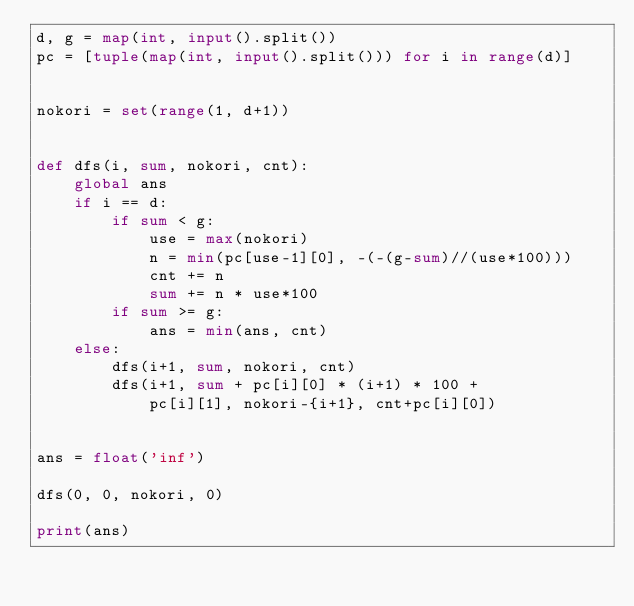<code> <loc_0><loc_0><loc_500><loc_500><_Python_>d, g = map(int, input().split())
pc = [tuple(map(int, input().split())) for i in range(d)]


nokori = set(range(1, d+1))


def dfs(i, sum, nokori, cnt):
    global ans
    if i == d:
        if sum < g:
            use = max(nokori)
            n = min(pc[use-1][0], -(-(g-sum)//(use*100)))
            cnt += n
            sum += n * use*100
        if sum >= g:
            ans = min(ans, cnt)
    else:
        dfs(i+1, sum, nokori, cnt)
        dfs(i+1, sum + pc[i][0] * (i+1) * 100 +
            pc[i][1], nokori-{i+1}, cnt+pc[i][0])


ans = float('inf')

dfs(0, 0, nokori, 0)

print(ans)
</code> 